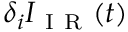<formula> <loc_0><loc_0><loc_500><loc_500>\delta _ { i } I _ { I R } ( t )</formula> 